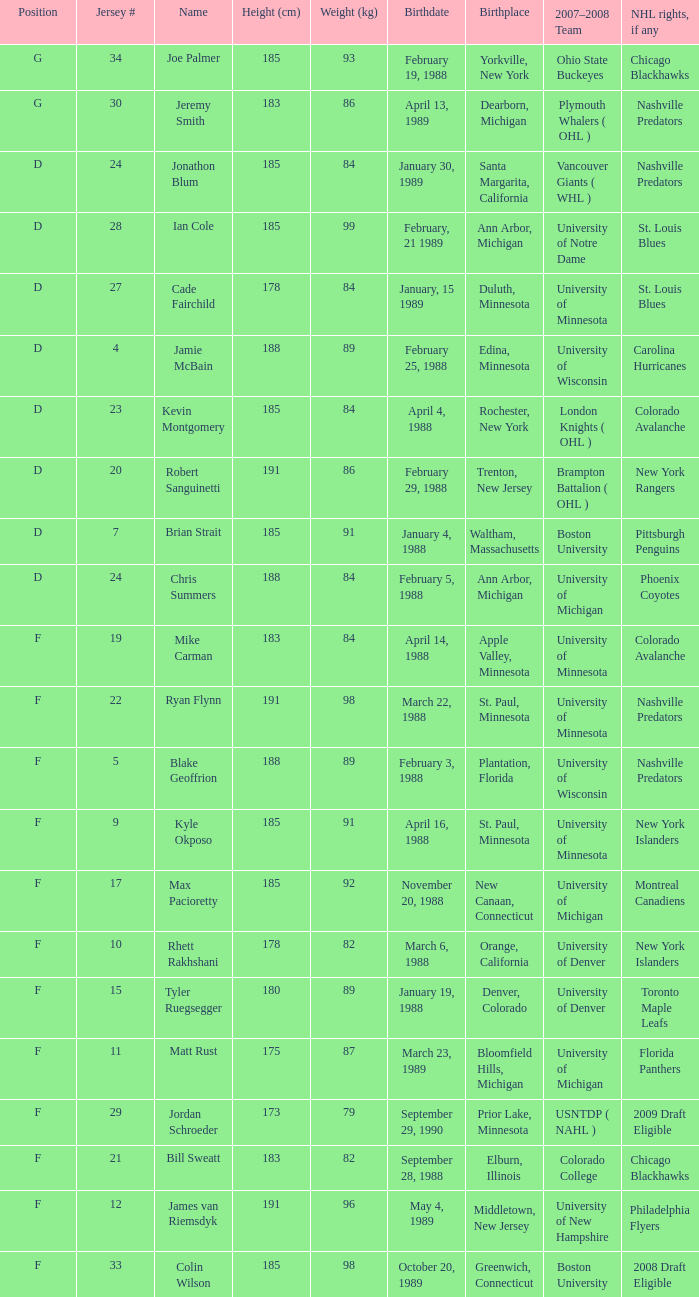Which Height (cm) has a Birthplace of bloomfield hills, michigan? 175.0. Can you give me this table as a dict? {'header': ['Position', 'Jersey #', 'Name', 'Height (cm)', 'Weight (kg)', 'Birthdate', 'Birthplace', '2007–2008 Team', 'NHL rights, if any'], 'rows': [['G', '34', 'Joe Palmer', '185', '93', 'February 19, 1988', 'Yorkville, New York', 'Ohio State Buckeyes', 'Chicago Blackhawks'], ['G', '30', 'Jeremy Smith', '183', '86', 'April 13, 1989', 'Dearborn, Michigan', 'Plymouth Whalers ( OHL )', 'Nashville Predators'], ['D', '24', 'Jonathon Blum', '185', '84', 'January 30, 1989', 'Santa Margarita, California', 'Vancouver Giants ( WHL )', 'Nashville Predators'], ['D', '28', 'Ian Cole', '185', '99', 'February, 21 1989', 'Ann Arbor, Michigan', 'University of Notre Dame', 'St. Louis Blues'], ['D', '27', 'Cade Fairchild', '178', '84', 'January, 15 1989', 'Duluth, Minnesota', 'University of Minnesota', 'St. Louis Blues'], ['D', '4', 'Jamie McBain', '188', '89', 'February 25, 1988', 'Edina, Minnesota', 'University of Wisconsin', 'Carolina Hurricanes'], ['D', '23', 'Kevin Montgomery', '185', '84', 'April 4, 1988', 'Rochester, New York', 'London Knights ( OHL )', 'Colorado Avalanche'], ['D', '20', 'Robert Sanguinetti', '191', '86', 'February 29, 1988', 'Trenton, New Jersey', 'Brampton Battalion ( OHL )', 'New York Rangers'], ['D', '7', 'Brian Strait', '185', '91', 'January 4, 1988', 'Waltham, Massachusetts', 'Boston University', 'Pittsburgh Penguins'], ['D', '24', 'Chris Summers', '188', '84', 'February 5, 1988', 'Ann Arbor, Michigan', 'University of Michigan', 'Phoenix Coyotes'], ['F', '19', 'Mike Carman', '183', '84', 'April 14, 1988', 'Apple Valley, Minnesota', 'University of Minnesota', 'Colorado Avalanche'], ['F', '22', 'Ryan Flynn', '191', '98', 'March 22, 1988', 'St. Paul, Minnesota', 'University of Minnesota', 'Nashville Predators'], ['F', '5', 'Blake Geoffrion', '188', '89', 'February 3, 1988', 'Plantation, Florida', 'University of Wisconsin', 'Nashville Predators'], ['F', '9', 'Kyle Okposo', '185', '91', 'April 16, 1988', 'St. Paul, Minnesota', 'University of Minnesota', 'New York Islanders'], ['F', '17', 'Max Pacioretty', '185', '92', 'November 20, 1988', 'New Canaan, Connecticut', 'University of Michigan', 'Montreal Canadiens'], ['F', '10', 'Rhett Rakhshani', '178', '82', 'March 6, 1988', 'Orange, California', 'University of Denver', 'New York Islanders'], ['F', '15', 'Tyler Ruegsegger', '180', '89', 'January 19, 1988', 'Denver, Colorado', 'University of Denver', 'Toronto Maple Leafs'], ['F', '11', 'Matt Rust', '175', '87', 'March 23, 1989', 'Bloomfield Hills, Michigan', 'University of Michigan', 'Florida Panthers'], ['F', '29', 'Jordan Schroeder', '173', '79', 'September 29, 1990', 'Prior Lake, Minnesota', 'USNTDP ( NAHL )', '2009 Draft Eligible'], ['F', '21', 'Bill Sweatt', '183', '82', 'September 28, 1988', 'Elburn, Illinois', 'Colorado College', 'Chicago Blackhawks'], ['F', '12', 'James van Riemsdyk', '191', '96', 'May 4, 1989', 'Middletown, New Jersey', 'University of New Hampshire', 'Philadelphia Flyers'], ['F', '33', 'Colin Wilson', '185', '98', 'October 20, 1989', 'Greenwich, Connecticut', 'Boston University', '2008 Draft Eligible']]} 